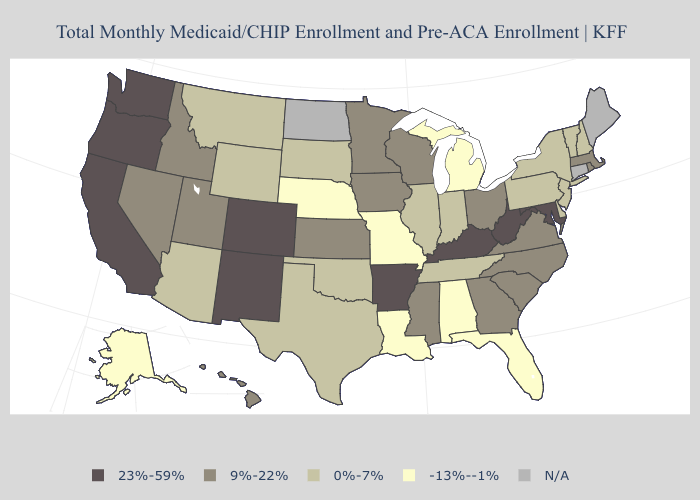Among the states that border New York , which have the lowest value?
Keep it brief. New Jersey, Pennsylvania, Vermont. Name the states that have a value in the range 9%-22%?
Be succinct. Georgia, Hawaii, Idaho, Iowa, Kansas, Massachusetts, Minnesota, Mississippi, Nevada, North Carolina, Ohio, Rhode Island, South Carolina, Utah, Virginia, Wisconsin. Which states have the lowest value in the Northeast?
Be succinct. New Hampshire, New Jersey, New York, Pennsylvania, Vermont. What is the highest value in states that border Maryland?
Give a very brief answer. 23%-59%. Among the states that border Ohio , does Kentucky have the lowest value?
Keep it brief. No. Among the states that border Massachusetts , which have the lowest value?
Keep it brief. New Hampshire, New York, Vermont. What is the value of Oklahoma?
Answer briefly. 0%-7%. Among the states that border Rhode Island , which have the lowest value?
Keep it brief. Massachusetts. What is the lowest value in the USA?
Write a very short answer. -13%--1%. What is the value of New Hampshire?
Answer briefly. 0%-7%. Does Wyoming have the highest value in the West?
Be succinct. No. Name the states that have a value in the range 0%-7%?
Answer briefly. Arizona, Delaware, Illinois, Indiana, Montana, New Hampshire, New Jersey, New York, Oklahoma, Pennsylvania, South Dakota, Tennessee, Texas, Vermont, Wyoming. Among the states that border Washington , which have the highest value?
Short answer required. Oregon. 